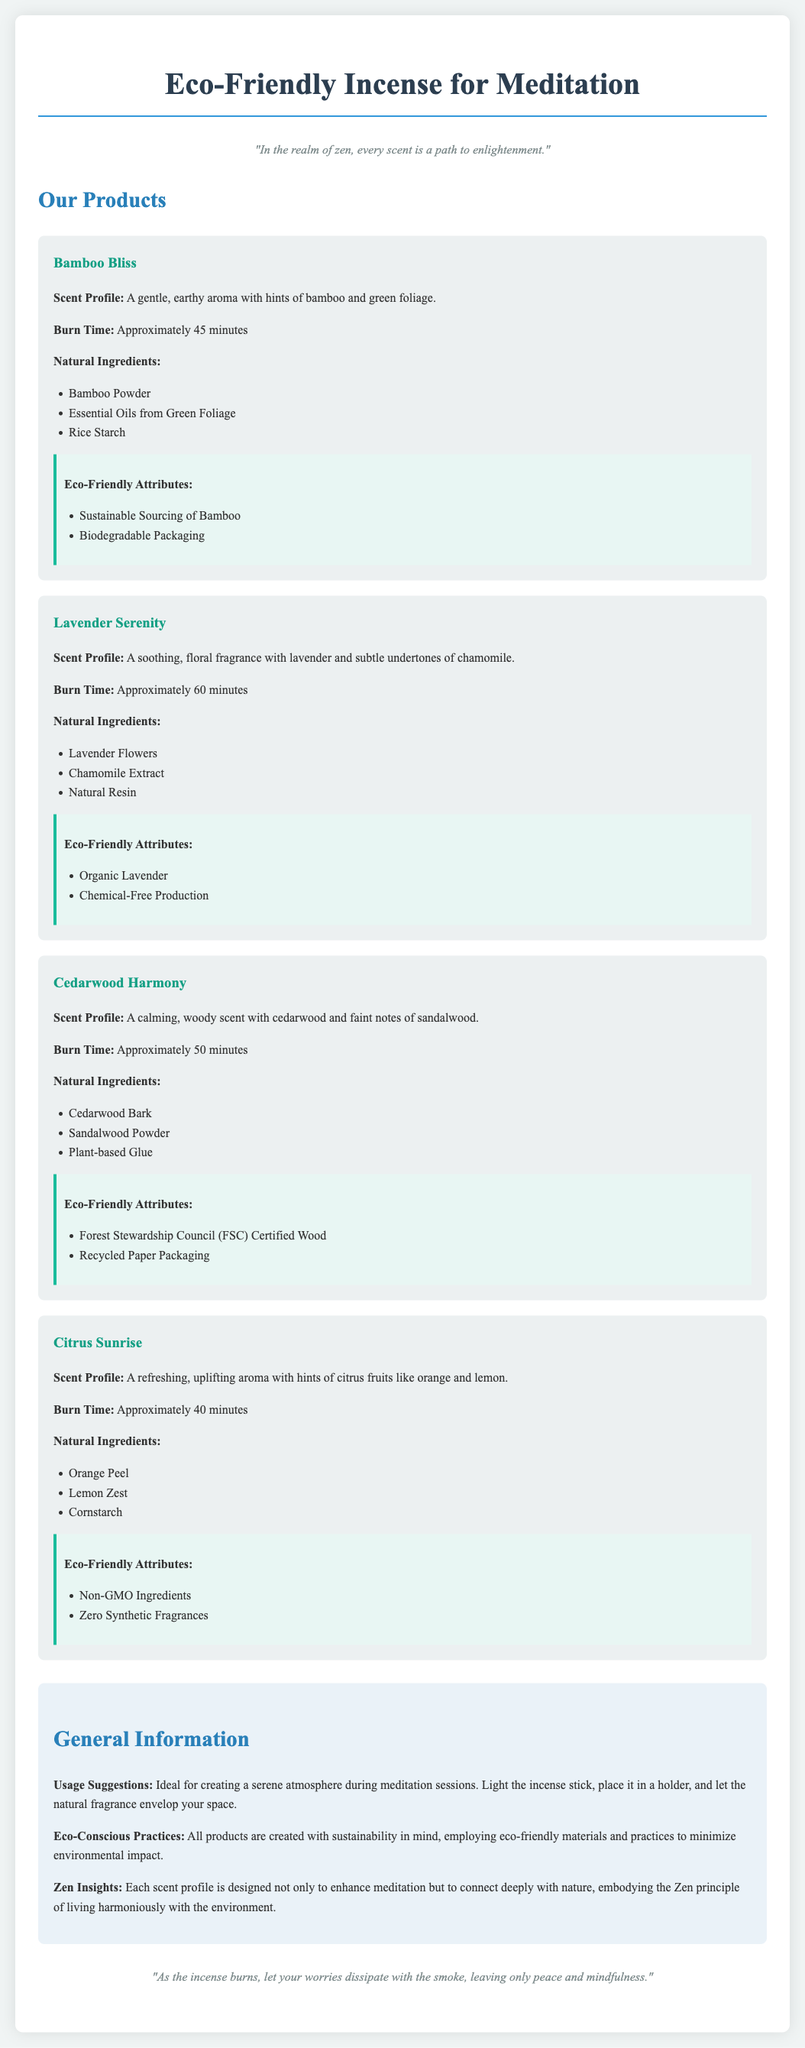What is the scent profile of Bamboo Bliss? The scent profile is described as a gentle, earthy aroma with hints of bamboo and green foliage.
Answer: A gentle, earthy aroma with hints of bamboo and green foliage What is the burn time of Lavender Serenity? The burn time for Lavender Serenity is stated to be approximately 60 minutes.
Answer: Approximately 60 minutes What are the natural ingredients of Cedarwood Harmony? The natural ingredients listed include Cedarwood Bark, Sandalwood Powder, and Plant-based Glue.
Answer: Cedarwood Bark, Sandalwood Powder, Plant-based Glue What eco-friendly attribute is associated with Citrus Sunrise? The document mentions that Citrus Sunrise features non-GMO ingredients as an eco-friendly attribute.
Answer: Non-GMO Ingredients How do the incense products contribute to eco-conscious practices? The products are created with sustainability in mind, employing eco-friendly materials and practices to minimize environmental impact.
Answer: Eco-friendly materials and practices What is the purpose of the incense according to the usage suggestions? The suggestions state that the incense is ideal for creating a serene atmosphere during meditation sessions.
Answer: Creating a serene atmosphere during meditation sessions Why is Lavender Serenity considered calming? The fragrance of Lavender Serenity includes soothing, floral notes which provide calming effects.
Answer: Soothing, floral fragrance Which product has the shortest burn time? The document indicates that Citrus Sunrise has the shortest burn time of approximately 40 minutes.
Answer: Approximately 40 minutes 